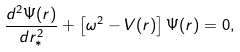Convert formula to latex. <formula><loc_0><loc_0><loc_500><loc_500>\frac { d ^ { 2 } \Psi ( r ) } { d r _ { * } ^ { 2 } } + \left [ \omega ^ { 2 } - V ( r ) \right ] \Psi ( r ) = 0 ,</formula> 